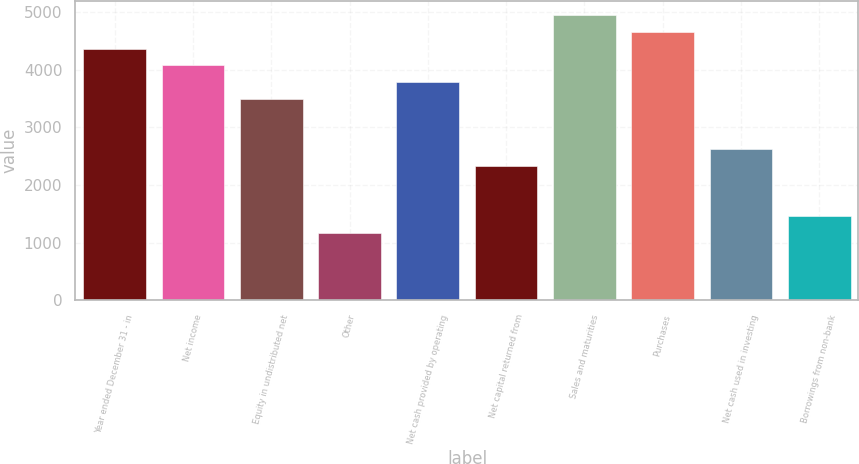Convert chart. <chart><loc_0><loc_0><loc_500><loc_500><bar_chart><fcel>Year ended December 31 - in<fcel>Net income<fcel>Equity in undistributed net<fcel>Other<fcel>Net cash provided by operating<fcel>Net capital returned from<fcel>Sales and maturities<fcel>Purchases<fcel>Net cash used in investing<fcel>Borrowings from non-bank<nl><fcel>4367.5<fcel>4076.4<fcel>3494.2<fcel>1165.4<fcel>3785.3<fcel>2329.8<fcel>4949.7<fcel>4658.6<fcel>2620.9<fcel>1456.5<nl></chart> 